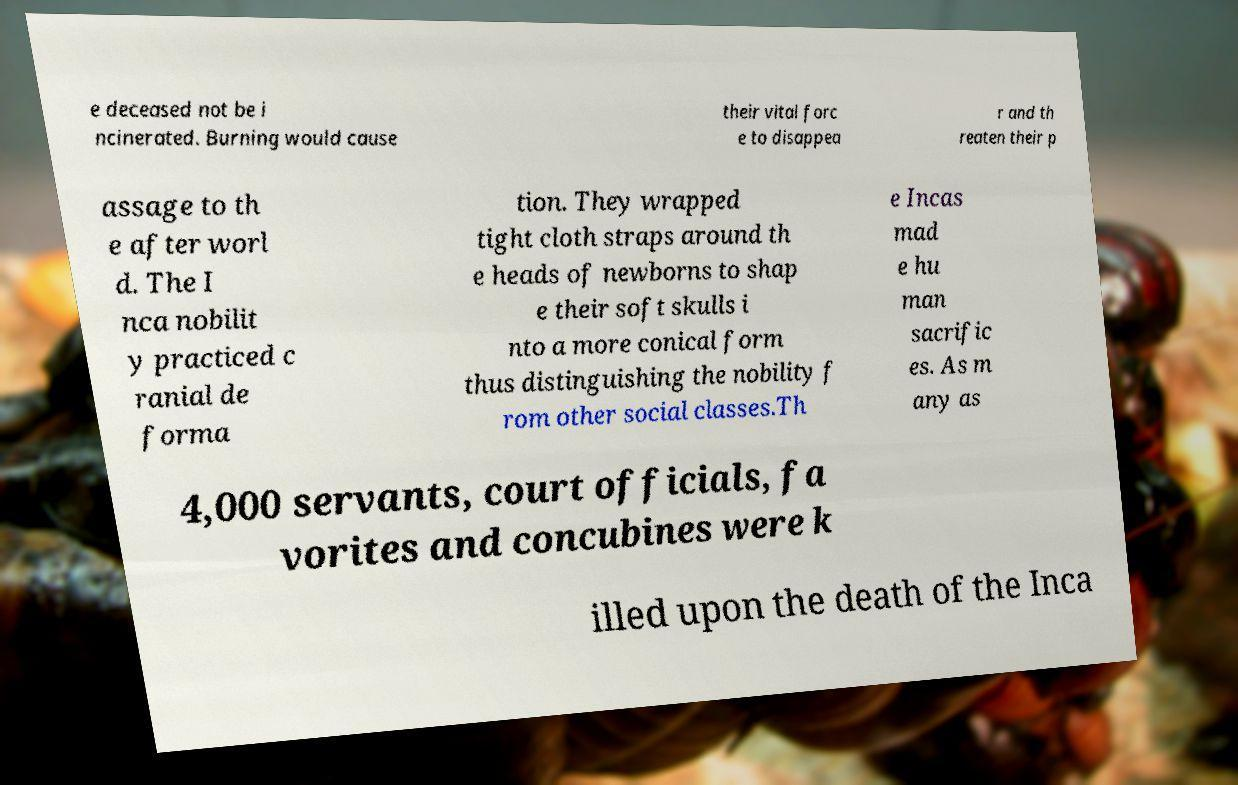What messages or text are displayed in this image? I need them in a readable, typed format. e deceased not be i ncinerated. Burning would cause their vital forc e to disappea r and th reaten their p assage to th e after worl d. The I nca nobilit y practiced c ranial de forma tion. They wrapped tight cloth straps around th e heads of newborns to shap e their soft skulls i nto a more conical form thus distinguishing the nobility f rom other social classes.Th e Incas mad e hu man sacrific es. As m any as 4,000 servants, court officials, fa vorites and concubines were k illed upon the death of the Inca 